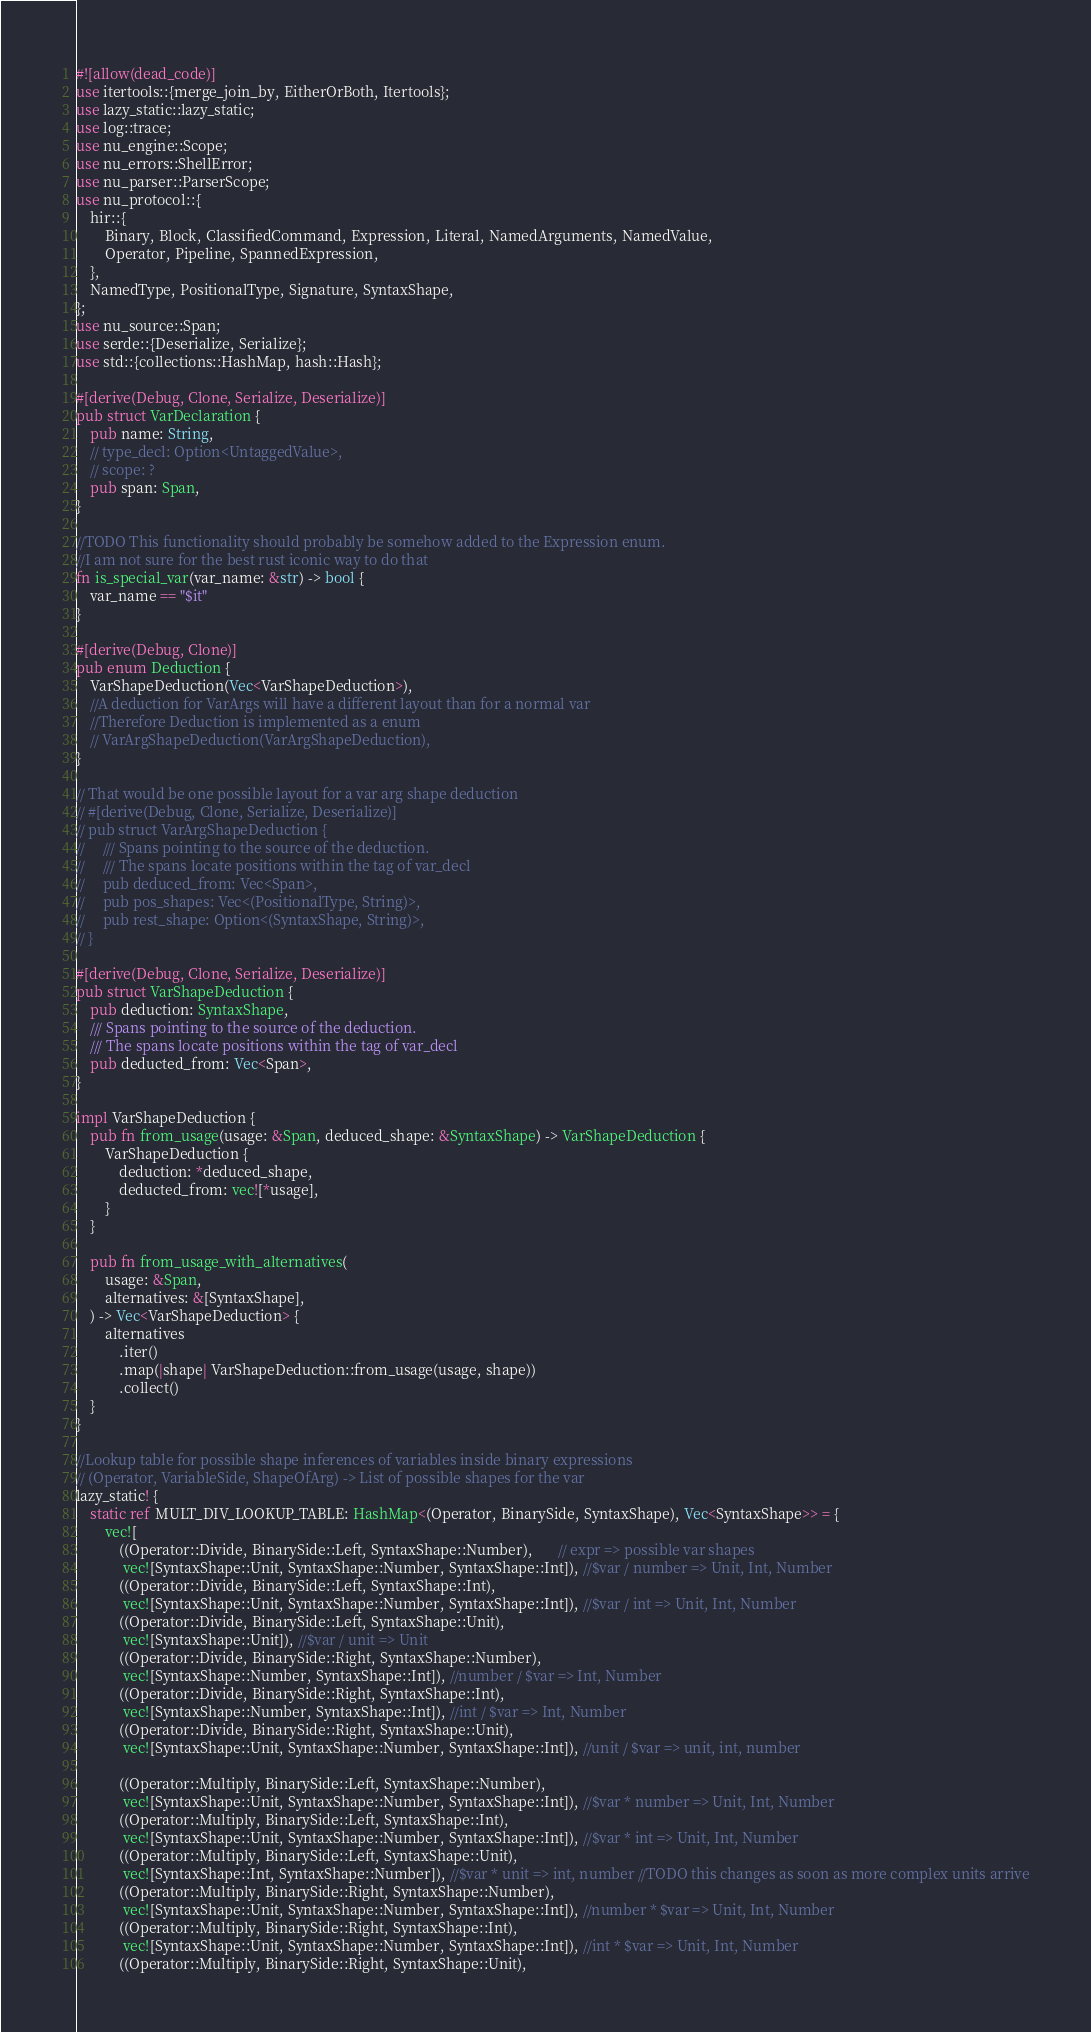Convert code to text. <code><loc_0><loc_0><loc_500><loc_500><_Rust_>#![allow(dead_code)]
use itertools::{merge_join_by, EitherOrBoth, Itertools};
use lazy_static::lazy_static;
use log::trace;
use nu_engine::Scope;
use nu_errors::ShellError;
use nu_parser::ParserScope;
use nu_protocol::{
    hir::{
        Binary, Block, ClassifiedCommand, Expression, Literal, NamedArguments, NamedValue,
        Operator, Pipeline, SpannedExpression,
    },
    NamedType, PositionalType, Signature, SyntaxShape,
};
use nu_source::Span;
use serde::{Deserialize, Serialize};
use std::{collections::HashMap, hash::Hash};

#[derive(Debug, Clone, Serialize, Deserialize)]
pub struct VarDeclaration {
    pub name: String,
    // type_decl: Option<UntaggedValue>,
    // scope: ?
    pub span: Span,
}

//TODO This functionality should probably be somehow added to the Expression enum.
//I am not sure for the best rust iconic way to do that
fn is_special_var(var_name: &str) -> bool {
    var_name == "$it"
}

#[derive(Debug, Clone)]
pub enum Deduction {
    VarShapeDeduction(Vec<VarShapeDeduction>),
    //A deduction for VarArgs will have a different layout than for a normal var
    //Therefore Deduction is implemented as a enum
    // VarArgShapeDeduction(VarArgShapeDeduction),
}

// That would be one possible layout for a var arg shape deduction
// #[derive(Debug, Clone, Serialize, Deserialize)]
// pub struct VarArgShapeDeduction {
//     /// Spans pointing to the source of the deduction.
//     /// The spans locate positions within the tag of var_decl
//     pub deduced_from: Vec<Span>,
//     pub pos_shapes: Vec<(PositionalType, String)>,
//     pub rest_shape: Option<(SyntaxShape, String)>,
// }

#[derive(Debug, Clone, Serialize, Deserialize)]
pub struct VarShapeDeduction {
    pub deduction: SyntaxShape,
    /// Spans pointing to the source of the deduction.
    /// The spans locate positions within the tag of var_decl
    pub deducted_from: Vec<Span>,
}

impl VarShapeDeduction {
    pub fn from_usage(usage: &Span, deduced_shape: &SyntaxShape) -> VarShapeDeduction {
        VarShapeDeduction {
            deduction: *deduced_shape,
            deducted_from: vec![*usage],
        }
    }

    pub fn from_usage_with_alternatives(
        usage: &Span,
        alternatives: &[SyntaxShape],
    ) -> Vec<VarShapeDeduction> {
        alternatives
            .iter()
            .map(|shape| VarShapeDeduction::from_usage(usage, shape))
            .collect()
    }
}

//Lookup table for possible shape inferences of variables inside binary expressions
// (Operator, VariableSide, ShapeOfArg) -> List of possible shapes for the var
lazy_static! {
    static ref MULT_DIV_LOOKUP_TABLE: HashMap<(Operator, BinarySide, SyntaxShape), Vec<SyntaxShape>> = {
        vec![
            ((Operator::Divide, BinarySide::Left, SyntaxShape::Number),       // expr => possible var shapes
             vec![SyntaxShape::Unit, SyntaxShape::Number, SyntaxShape::Int]), //$var / number => Unit, Int, Number
            ((Operator::Divide, BinarySide::Left, SyntaxShape::Int),
             vec![SyntaxShape::Unit, SyntaxShape::Number, SyntaxShape::Int]), //$var / int => Unit, Int, Number
            ((Operator::Divide, BinarySide::Left, SyntaxShape::Unit),
             vec![SyntaxShape::Unit]), //$var / unit => Unit
            ((Operator::Divide, BinarySide::Right, SyntaxShape::Number),
             vec![SyntaxShape::Number, SyntaxShape::Int]), //number / $var => Int, Number
            ((Operator::Divide, BinarySide::Right, SyntaxShape::Int),
             vec![SyntaxShape::Number, SyntaxShape::Int]), //int / $var => Int, Number
            ((Operator::Divide, BinarySide::Right, SyntaxShape::Unit),
             vec![SyntaxShape::Unit, SyntaxShape::Number, SyntaxShape::Int]), //unit / $var => unit, int, number

            ((Operator::Multiply, BinarySide::Left, SyntaxShape::Number),
             vec![SyntaxShape::Unit, SyntaxShape::Number, SyntaxShape::Int]), //$var * number => Unit, Int, Number
            ((Operator::Multiply, BinarySide::Left, SyntaxShape::Int),
             vec![SyntaxShape::Unit, SyntaxShape::Number, SyntaxShape::Int]), //$var * int => Unit, Int, Number
            ((Operator::Multiply, BinarySide::Left, SyntaxShape::Unit),
             vec![SyntaxShape::Int, SyntaxShape::Number]), //$var * unit => int, number //TODO this changes as soon as more complex units arrive
            ((Operator::Multiply, BinarySide::Right, SyntaxShape::Number),
             vec![SyntaxShape::Unit, SyntaxShape::Number, SyntaxShape::Int]), //number * $var => Unit, Int, Number
            ((Operator::Multiply, BinarySide::Right, SyntaxShape::Int),
             vec![SyntaxShape::Unit, SyntaxShape::Number, SyntaxShape::Int]), //int * $var => Unit, Int, Number
            ((Operator::Multiply, BinarySide::Right, SyntaxShape::Unit),</code> 